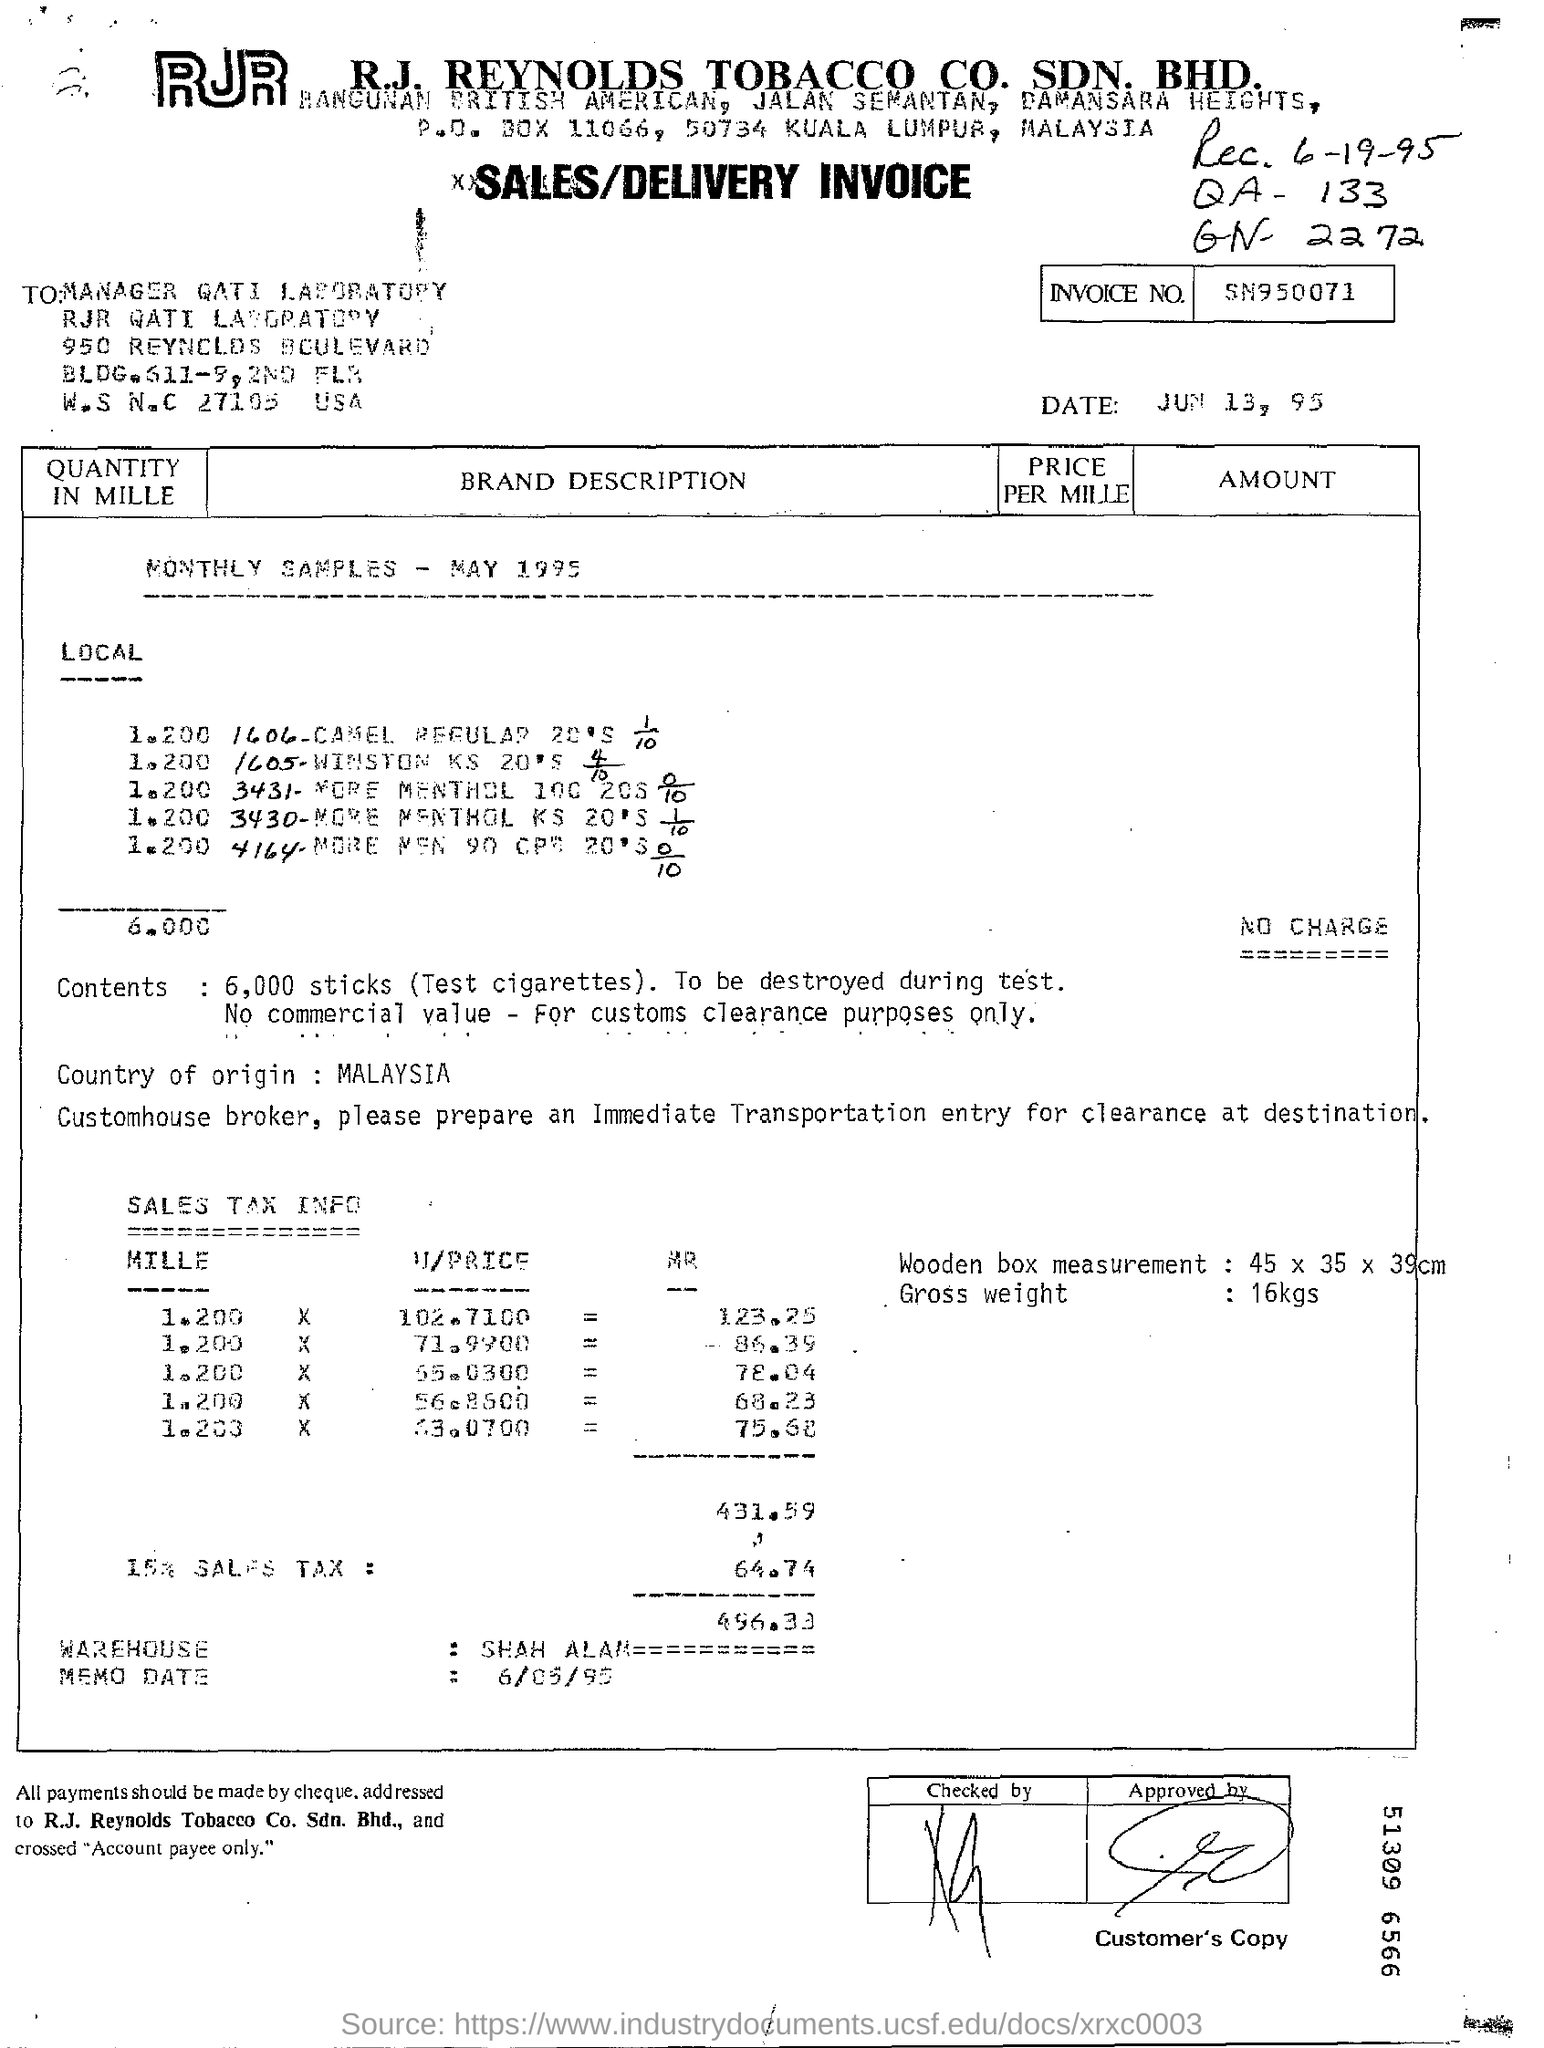What type of documentation is this?
Give a very brief answer. Sales/delivery invoice. What is the invoice number?
Ensure brevity in your answer.  SN950071. When is the invoice dated?
Make the answer very short. JUN 13, 95. What is the country of origin?
Offer a terse response. Malaysia. What is the gross weight of items?
Offer a very short reply. 16kgs. 